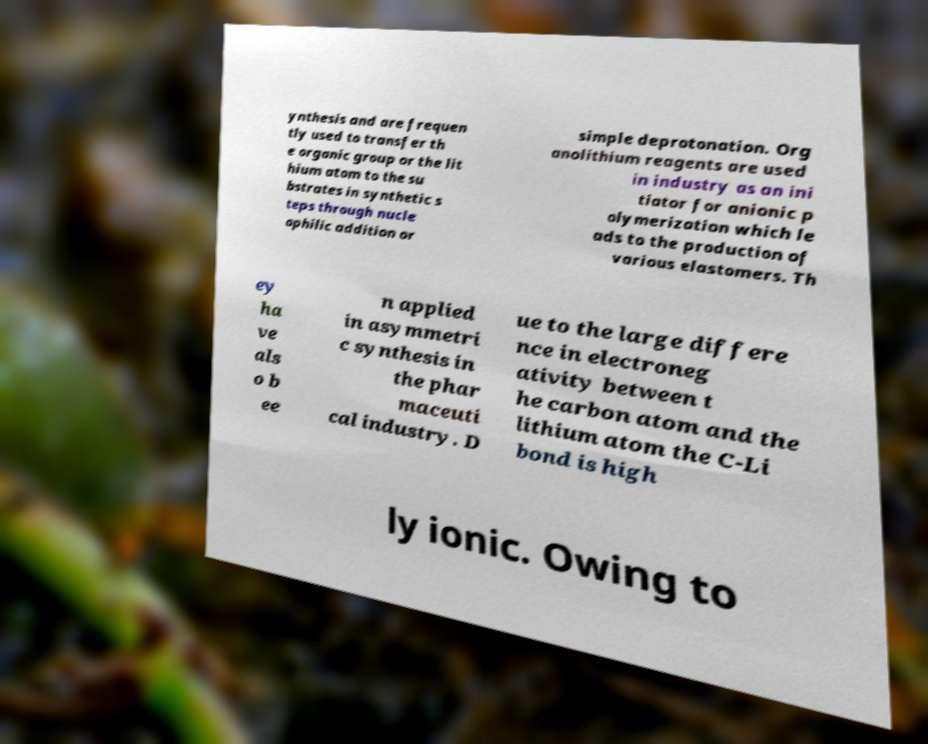Could you assist in decoding the text presented in this image and type it out clearly? ynthesis and are frequen tly used to transfer th e organic group or the lit hium atom to the su bstrates in synthetic s teps through nucle ophilic addition or simple deprotonation. Org anolithium reagents are used in industry as an ini tiator for anionic p olymerization which le ads to the production of various elastomers. Th ey ha ve als o b ee n applied in asymmetri c synthesis in the phar maceuti cal industry. D ue to the large differe nce in electroneg ativity between t he carbon atom and the lithium atom the C-Li bond is high ly ionic. Owing to 